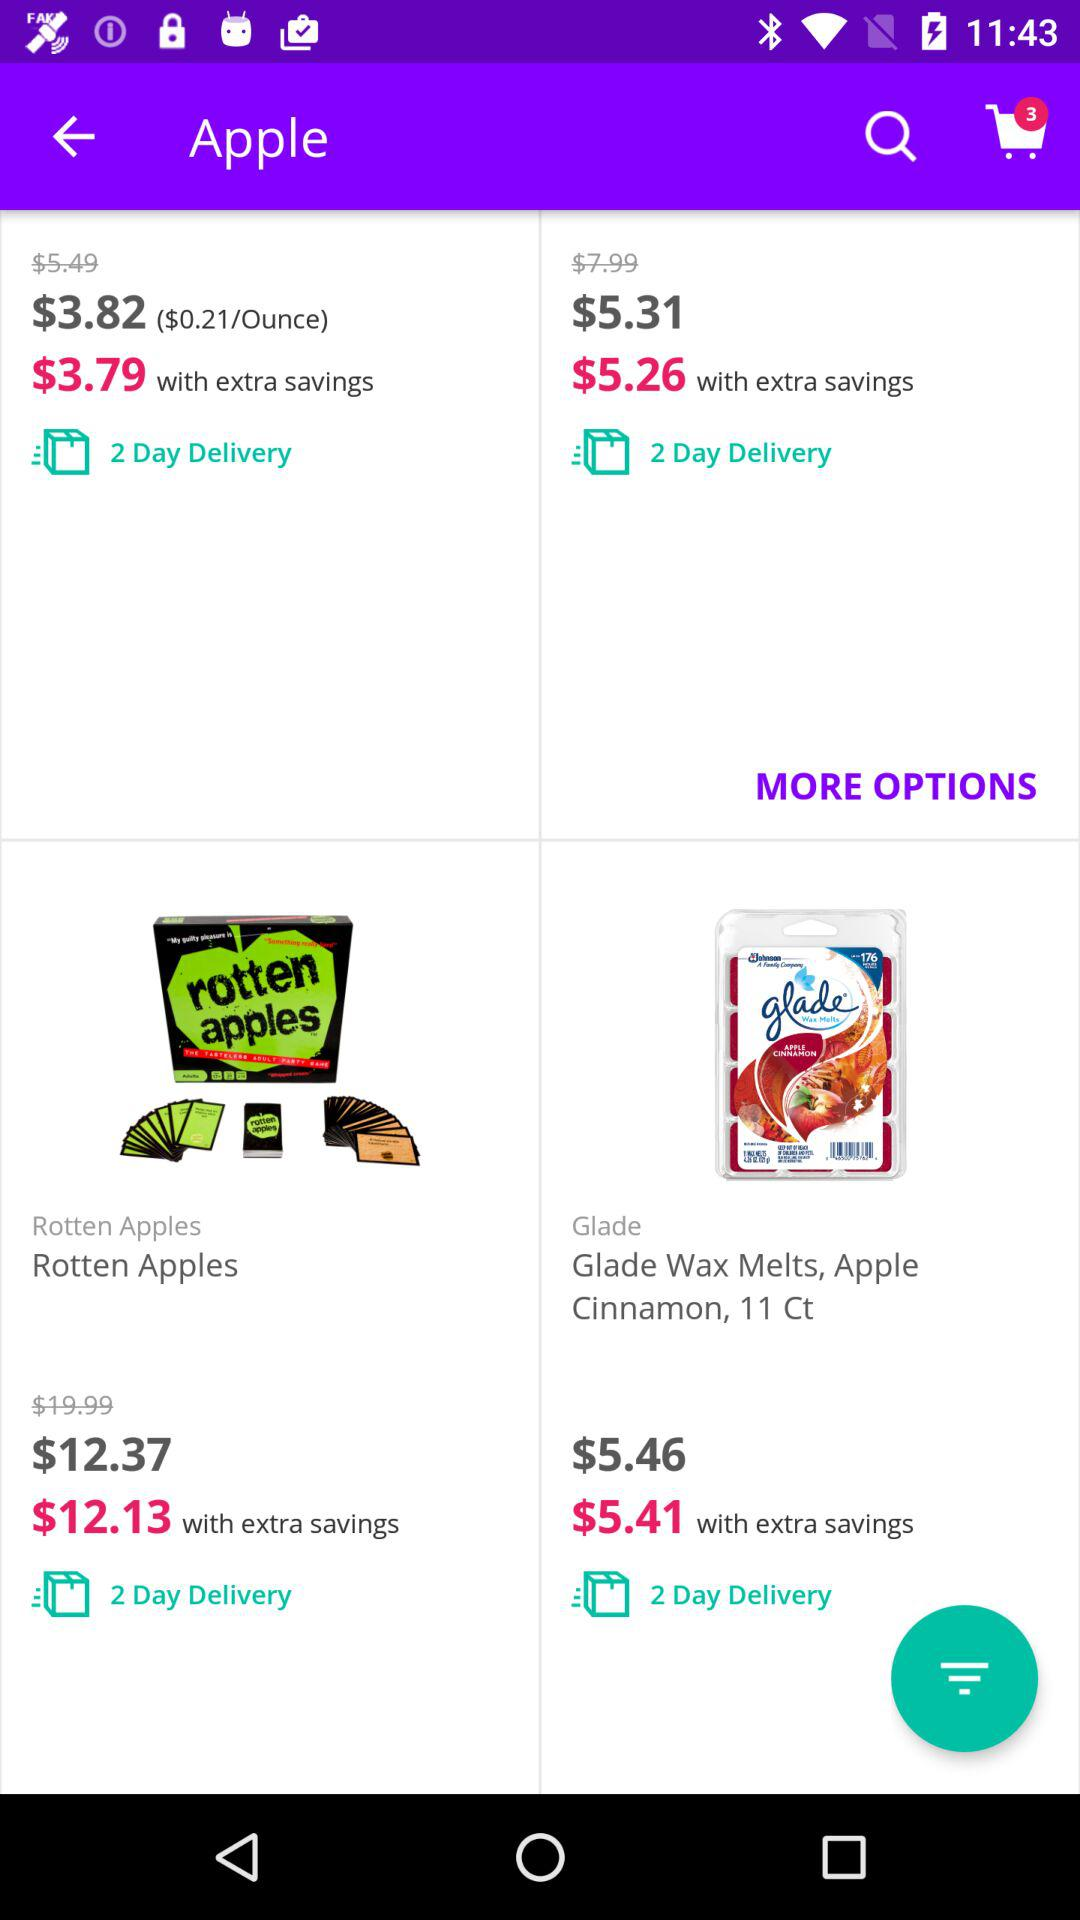What is the total number of items added to the cart? The total number of added items is 3. 